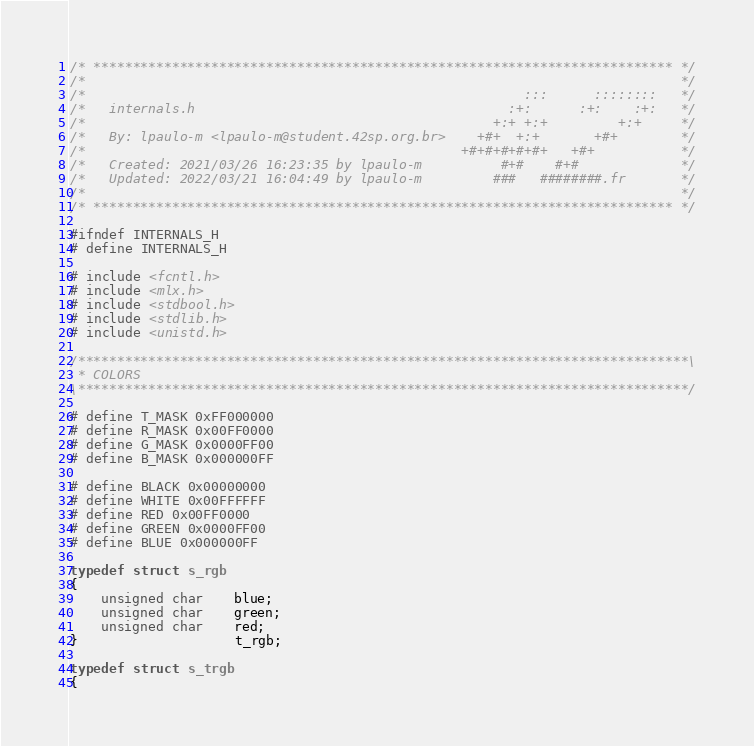Convert code to text. <code><loc_0><loc_0><loc_500><loc_500><_C_>/* ************************************************************************** */
/*                                                                            */
/*                                                        :::      ::::::::   */
/*   internals.h                                        :+:      :+:    :+:   */
/*                                                    +:+ +:+         +:+     */
/*   By: lpaulo-m <lpaulo-m@student.42sp.org.br>    +#+  +:+       +#+        */
/*                                                +#+#+#+#+#+   +#+           */
/*   Created: 2021/03/26 16:23:35 by lpaulo-m          #+#    #+#             */
/*   Updated: 2022/03/21 16:04:49 by lpaulo-m         ###   ########.fr       */
/*                                                                            */
/* ************************************************************************** */

#ifndef INTERNALS_H
# define INTERNALS_H

# include <fcntl.h>
# include <mlx.h>
# include <stdbool.h>
# include <stdlib.h>
# include <unistd.h>

/******************************************************************************\
 * COLORS
\******************************************************************************/

# define T_MASK 0xFF000000
# define R_MASK 0x00FF0000
# define G_MASK 0x0000FF00
# define B_MASK 0x000000FF

# define BLACK 0x00000000
# define WHITE 0x00FFFFFF
# define RED 0x00FF0000
# define GREEN 0x0000FF00
# define BLUE 0x000000FF

typedef struct s_rgb
{
	unsigned char	blue;
	unsigned char	green;
	unsigned char	red;
}					t_rgb;

typedef struct s_trgb
{</code> 